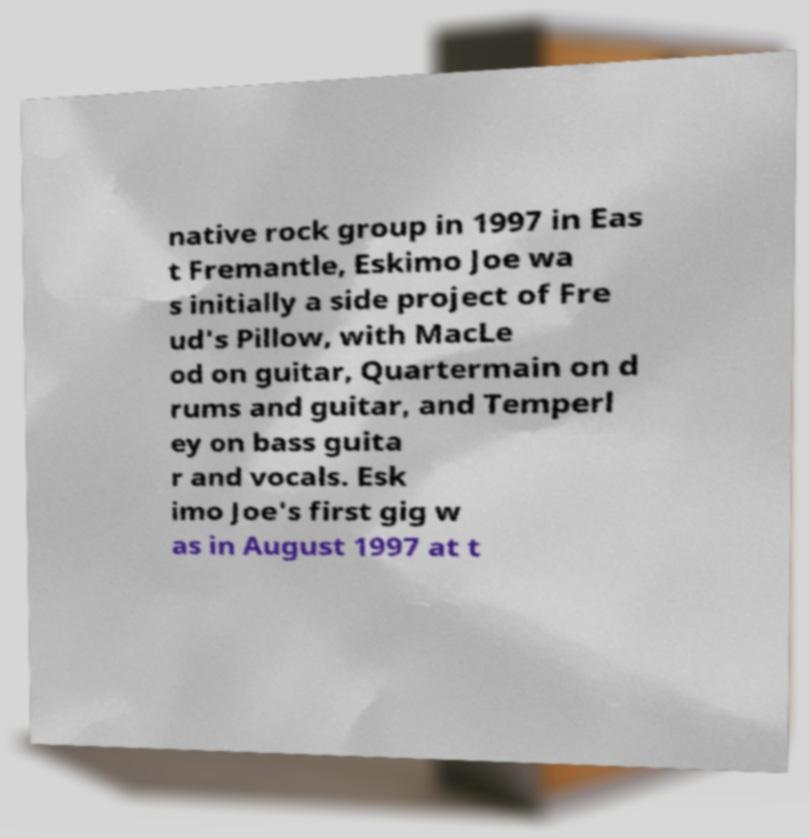Could you assist in decoding the text presented in this image and type it out clearly? native rock group in 1997 in Eas t Fremantle, Eskimo Joe wa s initially a side project of Fre ud's Pillow, with MacLe od on guitar, Quartermain on d rums and guitar, and Temperl ey on bass guita r and vocals. Esk imo Joe's first gig w as in August 1997 at t 